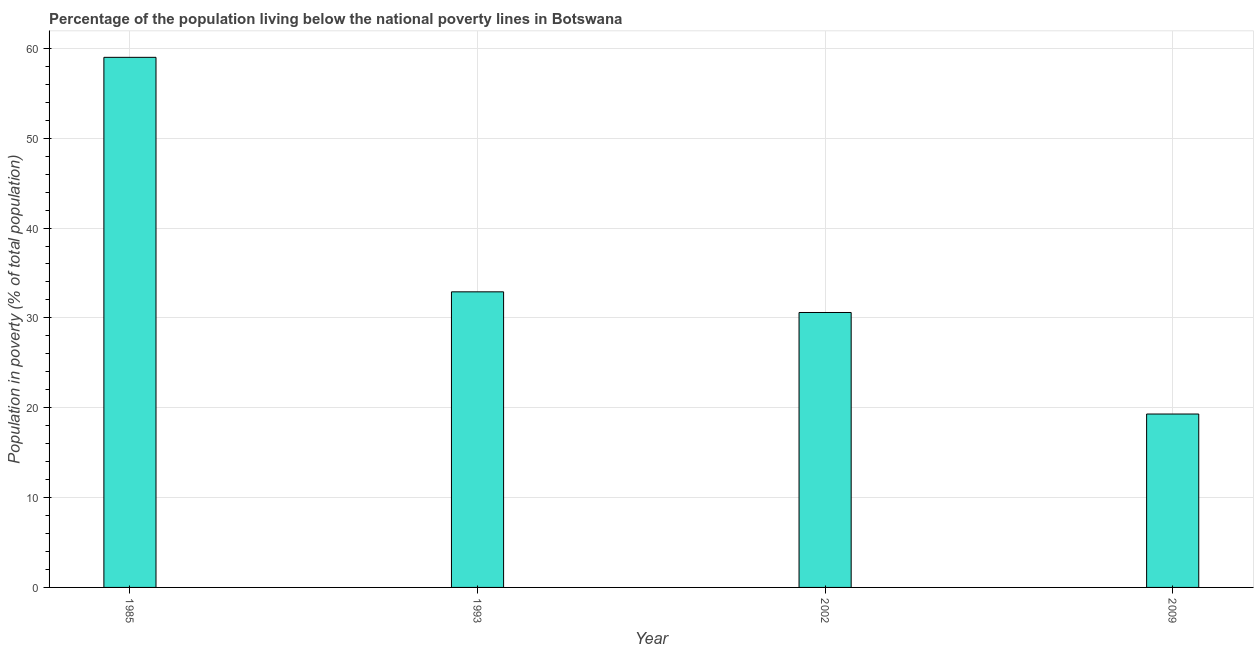What is the title of the graph?
Ensure brevity in your answer.  Percentage of the population living below the national poverty lines in Botswana. What is the label or title of the Y-axis?
Your answer should be compact. Population in poverty (% of total population). What is the percentage of population living below poverty line in 2002?
Offer a very short reply. 30.6. Across all years, what is the minimum percentage of population living below poverty line?
Your answer should be compact. 19.3. What is the sum of the percentage of population living below poverty line?
Offer a very short reply. 141.8. What is the difference between the percentage of population living below poverty line in 1993 and 2009?
Give a very brief answer. 13.6. What is the average percentage of population living below poverty line per year?
Offer a very short reply. 35.45. What is the median percentage of population living below poverty line?
Provide a succinct answer. 31.75. In how many years, is the percentage of population living below poverty line greater than 58 %?
Give a very brief answer. 1. Do a majority of the years between 1985 and 2009 (inclusive) have percentage of population living below poverty line greater than 32 %?
Ensure brevity in your answer.  No. What is the ratio of the percentage of population living below poverty line in 2002 to that in 2009?
Your answer should be compact. 1.58. Is the percentage of population living below poverty line in 1993 less than that in 2002?
Give a very brief answer. No. Is the difference between the percentage of population living below poverty line in 1993 and 2009 greater than the difference between any two years?
Provide a succinct answer. No. What is the difference between the highest and the second highest percentage of population living below poverty line?
Offer a terse response. 26.1. Is the sum of the percentage of population living below poverty line in 1985 and 2002 greater than the maximum percentage of population living below poverty line across all years?
Your answer should be compact. Yes. What is the difference between the highest and the lowest percentage of population living below poverty line?
Your response must be concise. 39.7. Are all the bars in the graph horizontal?
Keep it short and to the point. No. How many years are there in the graph?
Your response must be concise. 4. What is the difference between two consecutive major ticks on the Y-axis?
Give a very brief answer. 10. Are the values on the major ticks of Y-axis written in scientific E-notation?
Offer a very short reply. No. What is the Population in poverty (% of total population) in 1985?
Provide a short and direct response. 59. What is the Population in poverty (% of total population) in 1993?
Offer a terse response. 32.9. What is the Population in poverty (% of total population) in 2002?
Ensure brevity in your answer.  30.6. What is the Population in poverty (% of total population) in 2009?
Provide a short and direct response. 19.3. What is the difference between the Population in poverty (% of total population) in 1985 and 1993?
Provide a succinct answer. 26.1. What is the difference between the Population in poverty (% of total population) in 1985 and 2002?
Your answer should be compact. 28.4. What is the difference between the Population in poverty (% of total population) in 1985 and 2009?
Provide a short and direct response. 39.7. What is the ratio of the Population in poverty (% of total population) in 1985 to that in 1993?
Give a very brief answer. 1.79. What is the ratio of the Population in poverty (% of total population) in 1985 to that in 2002?
Ensure brevity in your answer.  1.93. What is the ratio of the Population in poverty (% of total population) in 1985 to that in 2009?
Offer a terse response. 3.06. What is the ratio of the Population in poverty (% of total population) in 1993 to that in 2002?
Give a very brief answer. 1.07. What is the ratio of the Population in poverty (% of total population) in 1993 to that in 2009?
Keep it short and to the point. 1.71. What is the ratio of the Population in poverty (% of total population) in 2002 to that in 2009?
Your answer should be very brief. 1.58. 